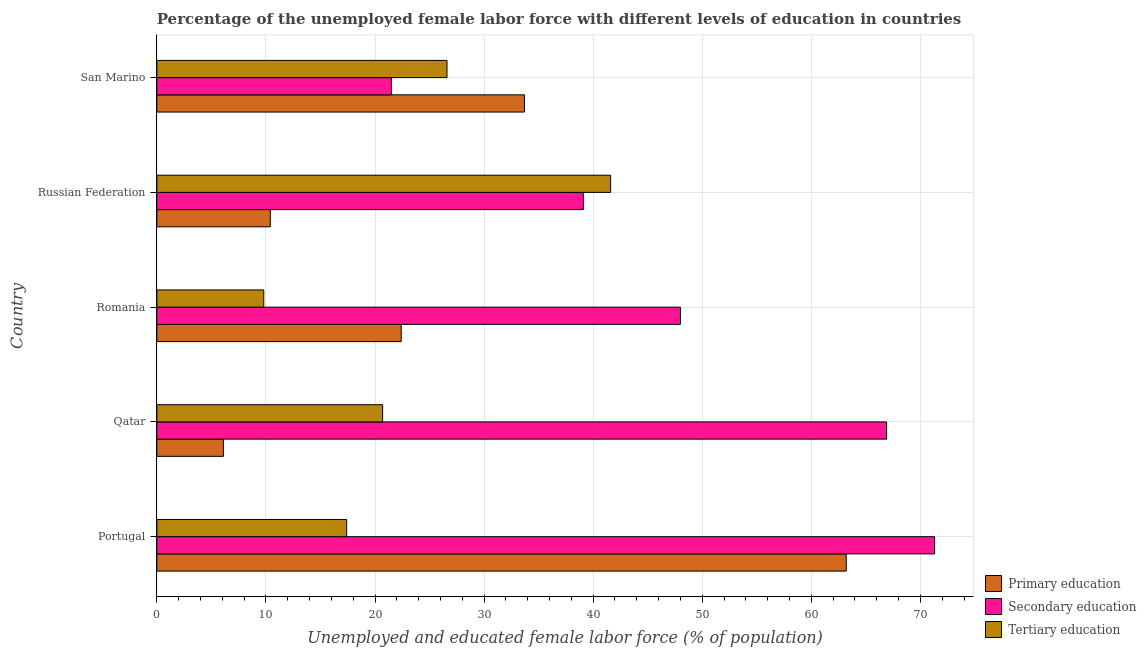How many groups of bars are there?
Keep it short and to the point. 5. Are the number of bars on each tick of the Y-axis equal?
Offer a terse response. Yes. How many bars are there on the 1st tick from the top?
Provide a succinct answer. 3. What is the percentage of female labor force who received primary education in Qatar?
Your response must be concise. 6.1. Across all countries, what is the maximum percentage of female labor force who received secondary education?
Provide a short and direct response. 71.3. In which country was the percentage of female labor force who received tertiary education minimum?
Offer a terse response. Romania. What is the total percentage of female labor force who received tertiary education in the graph?
Offer a very short reply. 116.1. What is the difference between the percentage of female labor force who received tertiary education in Portugal and that in San Marino?
Your answer should be compact. -9.2. What is the difference between the percentage of female labor force who received secondary education in San Marino and the percentage of female labor force who received primary education in Qatar?
Make the answer very short. 15.4. What is the average percentage of female labor force who received tertiary education per country?
Your answer should be very brief. 23.22. What is the difference between the percentage of female labor force who received secondary education and percentage of female labor force who received tertiary education in Portugal?
Your answer should be compact. 53.9. In how many countries, is the percentage of female labor force who received secondary education greater than 72 %?
Your answer should be compact. 0. What is the ratio of the percentage of female labor force who received tertiary education in Portugal to that in Russian Federation?
Keep it short and to the point. 0.42. Is the difference between the percentage of female labor force who received tertiary education in Qatar and Romania greater than the difference between the percentage of female labor force who received secondary education in Qatar and Romania?
Offer a terse response. No. What is the difference between the highest and the second highest percentage of female labor force who received secondary education?
Your answer should be very brief. 4.4. What is the difference between the highest and the lowest percentage of female labor force who received secondary education?
Give a very brief answer. 49.8. In how many countries, is the percentage of female labor force who received primary education greater than the average percentage of female labor force who received primary education taken over all countries?
Give a very brief answer. 2. Is the sum of the percentage of female labor force who received primary education in Romania and Russian Federation greater than the maximum percentage of female labor force who received secondary education across all countries?
Provide a succinct answer. No. What does the 1st bar from the top in Qatar represents?
Ensure brevity in your answer.  Tertiary education. What does the 1st bar from the bottom in Romania represents?
Make the answer very short. Primary education. Is it the case that in every country, the sum of the percentage of female labor force who received primary education and percentage of female labor force who received secondary education is greater than the percentage of female labor force who received tertiary education?
Make the answer very short. Yes. How many bars are there?
Keep it short and to the point. 15. Are all the bars in the graph horizontal?
Your answer should be compact. Yes. Does the graph contain grids?
Offer a terse response. Yes. Where does the legend appear in the graph?
Give a very brief answer. Bottom right. How are the legend labels stacked?
Provide a short and direct response. Vertical. What is the title of the graph?
Provide a short and direct response. Percentage of the unemployed female labor force with different levels of education in countries. What is the label or title of the X-axis?
Give a very brief answer. Unemployed and educated female labor force (% of population). What is the label or title of the Y-axis?
Make the answer very short. Country. What is the Unemployed and educated female labor force (% of population) of Primary education in Portugal?
Offer a terse response. 63.2. What is the Unemployed and educated female labor force (% of population) in Secondary education in Portugal?
Your answer should be very brief. 71.3. What is the Unemployed and educated female labor force (% of population) of Tertiary education in Portugal?
Give a very brief answer. 17.4. What is the Unemployed and educated female labor force (% of population) of Primary education in Qatar?
Provide a short and direct response. 6.1. What is the Unemployed and educated female labor force (% of population) in Secondary education in Qatar?
Make the answer very short. 66.9. What is the Unemployed and educated female labor force (% of population) of Tertiary education in Qatar?
Keep it short and to the point. 20.7. What is the Unemployed and educated female labor force (% of population) of Primary education in Romania?
Provide a succinct answer. 22.4. What is the Unemployed and educated female labor force (% of population) of Tertiary education in Romania?
Your response must be concise. 9.8. What is the Unemployed and educated female labor force (% of population) of Primary education in Russian Federation?
Your response must be concise. 10.4. What is the Unemployed and educated female labor force (% of population) in Secondary education in Russian Federation?
Provide a short and direct response. 39.1. What is the Unemployed and educated female labor force (% of population) of Tertiary education in Russian Federation?
Your response must be concise. 41.6. What is the Unemployed and educated female labor force (% of population) in Primary education in San Marino?
Your answer should be very brief. 33.7. What is the Unemployed and educated female labor force (% of population) of Secondary education in San Marino?
Ensure brevity in your answer.  21.5. What is the Unemployed and educated female labor force (% of population) of Tertiary education in San Marino?
Your answer should be very brief. 26.6. Across all countries, what is the maximum Unemployed and educated female labor force (% of population) of Primary education?
Make the answer very short. 63.2. Across all countries, what is the maximum Unemployed and educated female labor force (% of population) in Secondary education?
Provide a succinct answer. 71.3. Across all countries, what is the maximum Unemployed and educated female labor force (% of population) in Tertiary education?
Your answer should be very brief. 41.6. Across all countries, what is the minimum Unemployed and educated female labor force (% of population) of Primary education?
Offer a terse response. 6.1. Across all countries, what is the minimum Unemployed and educated female labor force (% of population) of Secondary education?
Offer a very short reply. 21.5. Across all countries, what is the minimum Unemployed and educated female labor force (% of population) in Tertiary education?
Make the answer very short. 9.8. What is the total Unemployed and educated female labor force (% of population) of Primary education in the graph?
Keep it short and to the point. 135.8. What is the total Unemployed and educated female labor force (% of population) of Secondary education in the graph?
Your answer should be very brief. 246.8. What is the total Unemployed and educated female labor force (% of population) of Tertiary education in the graph?
Your answer should be very brief. 116.1. What is the difference between the Unemployed and educated female labor force (% of population) in Primary education in Portugal and that in Qatar?
Provide a succinct answer. 57.1. What is the difference between the Unemployed and educated female labor force (% of population) of Tertiary education in Portugal and that in Qatar?
Make the answer very short. -3.3. What is the difference between the Unemployed and educated female labor force (% of population) of Primary education in Portugal and that in Romania?
Your response must be concise. 40.8. What is the difference between the Unemployed and educated female labor force (% of population) in Secondary education in Portugal and that in Romania?
Make the answer very short. 23.3. What is the difference between the Unemployed and educated female labor force (% of population) of Primary education in Portugal and that in Russian Federation?
Your answer should be very brief. 52.8. What is the difference between the Unemployed and educated female labor force (% of population) of Secondary education in Portugal and that in Russian Federation?
Provide a succinct answer. 32.2. What is the difference between the Unemployed and educated female labor force (% of population) of Tertiary education in Portugal and that in Russian Federation?
Make the answer very short. -24.2. What is the difference between the Unemployed and educated female labor force (% of population) in Primary education in Portugal and that in San Marino?
Your answer should be compact. 29.5. What is the difference between the Unemployed and educated female labor force (% of population) in Secondary education in Portugal and that in San Marino?
Offer a terse response. 49.8. What is the difference between the Unemployed and educated female labor force (% of population) in Tertiary education in Portugal and that in San Marino?
Offer a very short reply. -9.2. What is the difference between the Unemployed and educated female labor force (% of population) in Primary education in Qatar and that in Romania?
Offer a terse response. -16.3. What is the difference between the Unemployed and educated female labor force (% of population) in Secondary education in Qatar and that in Romania?
Your answer should be very brief. 18.9. What is the difference between the Unemployed and educated female labor force (% of population) in Secondary education in Qatar and that in Russian Federation?
Ensure brevity in your answer.  27.8. What is the difference between the Unemployed and educated female labor force (% of population) of Tertiary education in Qatar and that in Russian Federation?
Provide a short and direct response. -20.9. What is the difference between the Unemployed and educated female labor force (% of population) of Primary education in Qatar and that in San Marino?
Your response must be concise. -27.6. What is the difference between the Unemployed and educated female labor force (% of population) in Secondary education in Qatar and that in San Marino?
Ensure brevity in your answer.  45.4. What is the difference between the Unemployed and educated female labor force (% of population) of Tertiary education in Qatar and that in San Marino?
Keep it short and to the point. -5.9. What is the difference between the Unemployed and educated female labor force (% of population) in Tertiary education in Romania and that in Russian Federation?
Give a very brief answer. -31.8. What is the difference between the Unemployed and educated female labor force (% of population) of Secondary education in Romania and that in San Marino?
Ensure brevity in your answer.  26.5. What is the difference between the Unemployed and educated female labor force (% of population) in Tertiary education in Romania and that in San Marino?
Your answer should be very brief. -16.8. What is the difference between the Unemployed and educated female labor force (% of population) of Primary education in Russian Federation and that in San Marino?
Your answer should be very brief. -23.3. What is the difference between the Unemployed and educated female labor force (% of population) of Secondary education in Russian Federation and that in San Marino?
Give a very brief answer. 17.6. What is the difference between the Unemployed and educated female labor force (% of population) in Tertiary education in Russian Federation and that in San Marino?
Your answer should be compact. 15. What is the difference between the Unemployed and educated female labor force (% of population) of Primary education in Portugal and the Unemployed and educated female labor force (% of population) of Secondary education in Qatar?
Make the answer very short. -3.7. What is the difference between the Unemployed and educated female labor force (% of population) in Primary education in Portugal and the Unemployed and educated female labor force (% of population) in Tertiary education in Qatar?
Your response must be concise. 42.5. What is the difference between the Unemployed and educated female labor force (% of population) of Secondary education in Portugal and the Unemployed and educated female labor force (% of population) of Tertiary education in Qatar?
Offer a terse response. 50.6. What is the difference between the Unemployed and educated female labor force (% of population) in Primary education in Portugal and the Unemployed and educated female labor force (% of population) in Secondary education in Romania?
Provide a succinct answer. 15.2. What is the difference between the Unemployed and educated female labor force (% of population) in Primary education in Portugal and the Unemployed and educated female labor force (% of population) in Tertiary education in Romania?
Provide a short and direct response. 53.4. What is the difference between the Unemployed and educated female labor force (% of population) of Secondary education in Portugal and the Unemployed and educated female labor force (% of population) of Tertiary education in Romania?
Provide a short and direct response. 61.5. What is the difference between the Unemployed and educated female labor force (% of population) of Primary education in Portugal and the Unemployed and educated female labor force (% of population) of Secondary education in Russian Federation?
Provide a succinct answer. 24.1. What is the difference between the Unemployed and educated female labor force (% of population) of Primary education in Portugal and the Unemployed and educated female labor force (% of population) of Tertiary education in Russian Federation?
Your response must be concise. 21.6. What is the difference between the Unemployed and educated female labor force (% of population) of Secondary education in Portugal and the Unemployed and educated female labor force (% of population) of Tertiary education in Russian Federation?
Provide a short and direct response. 29.7. What is the difference between the Unemployed and educated female labor force (% of population) of Primary education in Portugal and the Unemployed and educated female labor force (% of population) of Secondary education in San Marino?
Ensure brevity in your answer.  41.7. What is the difference between the Unemployed and educated female labor force (% of population) in Primary education in Portugal and the Unemployed and educated female labor force (% of population) in Tertiary education in San Marino?
Keep it short and to the point. 36.6. What is the difference between the Unemployed and educated female labor force (% of population) of Secondary education in Portugal and the Unemployed and educated female labor force (% of population) of Tertiary education in San Marino?
Your answer should be very brief. 44.7. What is the difference between the Unemployed and educated female labor force (% of population) of Primary education in Qatar and the Unemployed and educated female labor force (% of population) of Secondary education in Romania?
Make the answer very short. -41.9. What is the difference between the Unemployed and educated female labor force (% of population) of Primary education in Qatar and the Unemployed and educated female labor force (% of population) of Tertiary education in Romania?
Your answer should be compact. -3.7. What is the difference between the Unemployed and educated female labor force (% of population) in Secondary education in Qatar and the Unemployed and educated female labor force (% of population) in Tertiary education in Romania?
Offer a terse response. 57.1. What is the difference between the Unemployed and educated female labor force (% of population) of Primary education in Qatar and the Unemployed and educated female labor force (% of population) of Secondary education in Russian Federation?
Offer a terse response. -33. What is the difference between the Unemployed and educated female labor force (% of population) of Primary education in Qatar and the Unemployed and educated female labor force (% of population) of Tertiary education in Russian Federation?
Your answer should be compact. -35.5. What is the difference between the Unemployed and educated female labor force (% of population) of Secondary education in Qatar and the Unemployed and educated female labor force (% of population) of Tertiary education in Russian Federation?
Make the answer very short. 25.3. What is the difference between the Unemployed and educated female labor force (% of population) of Primary education in Qatar and the Unemployed and educated female labor force (% of population) of Secondary education in San Marino?
Offer a terse response. -15.4. What is the difference between the Unemployed and educated female labor force (% of population) of Primary education in Qatar and the Unemployed and educated female labor force (% of population) of Tertiary education in San Marino?
Keep it short and to the point. -20.5. What is the difference between the Unemployed and educated female labor force (% of population) in Secondary education in Qatar and the Unemployed and educated female labor force (% of population) in Tertiary education in San Marino?
Ensure brevity in your answer.  40.3. What is the difference between the Unemployed and educated female labor force (% of population) in Primary education in Romania and the Unemployed and educated female labor force (% of population) in Secondary education in Russian Federation?
Your answer should be compact. -16.7. What is the difference between the Unemployed and educated female labor force (% of population) in Primary education in Romania and the Unemployed and educated female labor force (% of population) in Tertiary education in Russian Federation?
Give a very brief answer. -19.2. What is the difference between the Unemployed and educated female labor force (% of population) of Secondary education in Romania and the Unemployed and educated female labor force (% of population) of Tertiary education in Russian Federation?
Make the answer very short. 6.4. What is the difference between the Unemployed and educated female labor force (% of population) in Primary education in Romania and the Unemployed and educated female labor force (% of population) in Tertiary education in San Marino?
Your answer should be compact. -4.2. What is the difference between the Unemployed and educated female labor force (% of population) in Secondary education in Romania and the Unemployed and educated female labor force (% of population) in Tertiary education in San Marino?
Offer a terse response. 21.4. What is the difference between the Unemployed and educated female labor force (% of population) in Primary education in Russian Federation and the Unemployed and educated female labor force (% of population) in Tertiary education in San Marino?
Ensure brevity in your answer.  -16.2. What is the difference between the Unemployed and educated female labor force (% of population) of Secondary education in Russian Federation and the Unemployed and educated female labor force (% of population) of Tertiary education in San Marino?
Offer a terse response. 12.5. What is the average Unemployed and educated female labor force (% of population) in Primary education per country?
Your response must be concise. 27.16. What is the average Unemployed and educated female labor force (% of population) in Secondary education per country?
Your response must be concise. 49.36. What is the average Unemployed and educated female labor force (% of population) of Tertiary education per country?
Provide a succinct answer. 23.22. What is the difference between the Unemployed and educated female labor force (% of population) of Primary education and Unemployed and educated female labor force (% of population) of Secondary education in Portugal?
Provide a short and direct response. -8.1. What is the difference between the Unemployed and educated female labor force (% of population) of Primary education and Unemployed and educated female labor force (% of population) of Tertiary education in Portugal?
Your answer should be very brief. 45.8. What is the difference between the Unemployed and educated female labor force (% of population) of Secondary education and Unemployed and educated female labor force (% of population) of Tertiary education in Portugal?
Offer a very short reply. 53.9. What is the difference between the Unemployed and educated female labor force (% of population) in Primary education and Unemployed and educated female labor force (% of population) in Secondary education in Qatar?
Provide a short and direct response. -60.8. What is the difference between the Unemployed and educated female labor force (% of population) of Primary education and Unemployed and educated female labor force (% of population) of Tertiary education in Qatar?
Provide a short and direct response. -14.6. What is the difference between the Unemployed and educated female labor force (% of population) in Secondary education and Unemployed and educated female labor force (% of population) in Tertiary education in Qatar?
Give a very brief answer. 46.2. What is the difference between the Unemployed and educated female labor force (% of population) of Primary education and Unemployed and educated female labor force (% of population) of Secondary education in Romania?
Provide a succinct answer. -25.6. What is the difference between the Unemployed and educated female labor force (% of population) in Primary education and Unemployed and educated female labor force (% of population) in Tertiary education in Romania?
Your answer should be very brief. 12.6. What is the difference between the Unemployed and educated female labor force (% of population) of Secondary education and Unemployed and educated female labor force (% of population) of Tertiary education in Romania?
Provide a short and direct response. 38.2. What is the difference between the Unemployed and educated female labor force (% of population) in Primary education and Unemployed and educated female labor force (% of population) in Secondary education in Russian Federation?
Your answer should be very brief. -28.7. What is the difference between the Unemployed and educated female labor force (% of population) in Primary education and Unemployed and educated female labor force (% of population) in Tertiary education in Russian Federation?
Your response must be concise. -31.2. What is the difference between the Unemployed and educated female labor force (% of population) of Primary education and Unemployed and educated female labor force (% of population) of Secondary education in San Marino?
Ensure brevity in your answer.  12.2. What is the difference between the Unemployed and educated female labor force (% of population) in Secondary education and Unemployed and educated female labor force (% of population) in Tertiary education in San Marino?
Keep it short and to the point. -5.1. What is the ratio of the Unemployed and educated female labor force (% of population) in Primary education in Portugal to that in Qatar?
Your response must be concise. 10.36. What is the ratio of the Unemployed and educated female labor force (% of population) in Secondary education in Portugal to that in Qatar?
Give a very brief answer. 1.07. What is the ratio of the Unemployed and educated female labor force (% of population) in Tertiary education in Portugal to that in Qatar?
Provide a short and direct response. 0.84. What is the ratio of the Unemployed and educated female labor force (% of population) of Primary education in Portugal to that in Romania?
Keep it short and to the point. 2.82. What is the ratio of the Unemployed and educated female labor force (% of population) in Secondary education in Portugal to that in Romania?
Offer a very short reply. 1.49. What is the ratio of the Unemployed and educated female labor force (% of population) in Tertiary education in Portugal to that in Romania?
Provide a short and direct response. 1.78. What is the ratio of the Unemployed and educated female labor force (% of population) of Primary education in Portugal to that in Russian Federation?
Offer a very short reply. 6.08. What is the ratio of the Unemployed and educated female labor force (% of population) in Secondary education in Portugal to that in Russian Federation?
Your answer should be compact. 1.82. What is the ratio of the Unemployed and educated female labor force (% of population) in Tertiary education in Portugal to that in Russian Federation?
Keep it short and to the point. 0.42. What is the ratio of the Unemployed and educated female labor force (% of population) of Primary education in Portugal to that in San Marino?
Your answer should be compact. 1.88. What is the ratio of the Unemployed and educated female labor force (% of population) in Secondary education in Portugal to that in San Marino?
Provide a succinct answer. 3.32. What is the ratio of the Unemployed and educated female labor force (% of population) in Tertiary education in Portugal to that in San Marino?
Give a very brief answer. 0.65. What is the ratio of the Unemployed and educated female labor force (% of population) in Primary education in Qatar to that in Romania?
Give a very brief answer. 0.27. What is the ratio of the Unemployed and educated female labor force (% of population) in Secondary education in Qatar to that in Romania?
Give a very brief answer. 1.39. What is the ratio of the Unemployed and educated female labor force (% of population) in Tertiary education in Qatar to that in Romania?
Provide a short and direct response. 2.11. What is the ratio of the Unemployed and educated female labor force (% of population) of Primary education in Qatar to that in Russian Federation?
Offer a terse response. 0.59. What is the ratio of the Unemployed and educated female labor force (% of population) in Secondary education in Qatar to that in Russian Federation?
Your answer should be very brief. 1.71. What is the ratio of the Unemployed and educated female labor force (% of population) of Tertiary education in Qatar to that in Russian Federation?
Offer a very short reply. 0.5. What is the ratio of the Unemployed and educated female labor force (% of population) of Primary education in Qatar to that in San Marino?
Provide a short and direct response. 0.18. What is the ratio of the Unemployed and educated female labor force (% of population) in Secondary education in Qatar to that in San Marino?
Your response must be concise. 3.11. What is the ratio of the Unemployed and educated female labor force (% of population) of Tertiary education in Qatar to that in San Marino?
Provide a succinct answer. 0.78. What is the ratio of the Unemployed and educated female labor force (% of population) of Primary education in Romania to that in Russian Federation?
Keep it short and to the point. 2.15. What is the ratio of the Unemployed and educated female labor force (% of population) of Secondary education in Romania to that in Russian Federation?
Offer a very short reply. 1.23. What is the ratio of the Unemployed and educated female labor force (% of population) of Tertiary education in Romania to that in Russian Federation?
Offer a very short reply. 0.24. What is the ratio of the Unemployed and educated female labor force (% of population) of Primary education in Romania to that in San Marino?
Provide a succinct answer. 0.66. What is the ratio of the Unemployed and educated female labor force (% of population) in Secondary education in Romania to that in San Marino?
Provide a succinct answer. 2.23. What is the ratio of the Unemployed and educated female labor force (% of population) in Tertiary education in Romania to that in San Marino?
Keep it short and to the point. 0.37. What is the ratio of the Unemployed and educated female labor force (% of population) in Primary education in Russian Federation to that in San Marino?
Your response must be concise. 0.31. What is the ratio of the Unemployed and educated female labor force (% of population) in Secondary education in Russian Federation to that in San Marino?
Ensure brevity in your answer.  1.82. What is the ratio of the Unemployed and educated female labor force (% of population) in Tertiary education in Russian Federation to that in San Marino?
Your response must be concise. 1.56. What is the difference between the highest and the second highest Unemployed and educated female labor force (% of population) in Primary education?
Your answer should be very brief. 29.5. What is the difference between the highest and the lowest Unemployed and educated female labor force (% of population) in Primary education?
Your answer should be very brief. 57.1. What is the difference between the highest and the lowest Unemployed and educated female labor force (% of population) of Secondary education?
Provide a succinct answer. 49.8. What is the difference between the highest and the lowest Unemployed and educated female labor force (% of population) of Tertiary education?
Your answer should be compact. 31.8. 